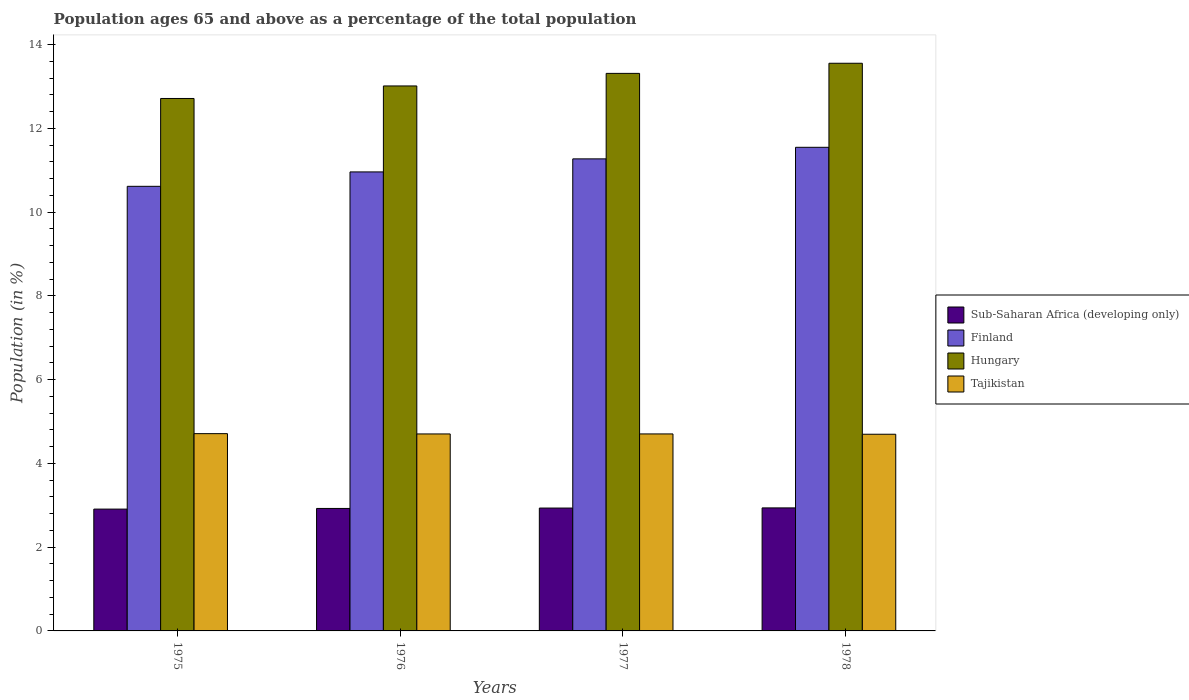How many different coloured bars are there?
Keep it short and to the point. 4. Are the number of bars on each tick of the X-axis equal?
Your answer should be very brief. Yes. How many bars are there on the 4th tick from the right?
Ensure brevity in your answer.  4. What is the label of the 2nd group of bars from the left?
Make the answer very short. 1976. What is the percentage of the population ages 65 and above in Tajikistan in 1975?
Give a very brief answer. 4.71. Across all years, what is the maximum percentage of the population ages 65 and above in Finland?
Offer a very short reply. 11.55. Across all years, what is the minimum percentage of the population ages 65 and above in Hungary?
Offer a terse response. 12.71. In which year was the percentage of the population ages 65 and above in Hungary maximum?
Your response must be concise. 1978. In which year was the percentage of the population ages 65 and above in Tajikistan minimum?
Provide a short and direct response. 1978. What is the total percentage of the population ages 65 and above in Sub-Saharan Africa (developing only) in the graph?
Your response must be concise. 11.7. What is the difference between the percentage of the population ages 65 and above in Hungary in 1976 and that in 1978?
Ensure brevity in your answer.  -0.54. What is the difference between the percentage of the population ages 65 and above in Finland in 1977 and the percentage of the population ages 65 and above in Sub-Saharan Africa (developing only) in 1978?
Offer a terse response. 8.33. What is the average percentage of the population ages 65 and above in Finland per year?
Keep it short and to the point. 11.1. In the year 1975, what is the difference between the percentage of the population ages 65 and above in Finland and percentage of the population ages 65 and above in Tajikistan?
Provide a succinct answer. 5.91. In how many years, is the percentage of the population ages 65 and above in Sub-Saharan Africa (developing only) greater than 0.4?
Provide a succinct answer. 4. What is the ratio of the percentage of the population ages 65 and above in Hungary in 1976 to that in 1977?
Give a very brief answer. 0.98. Is the percentage of the population ages 65 and above in Sub-Saharan Africa (developing only) in 1976 less than that in 1977?
Offer a terse response. Yes. What is the difference between the highest and the second highest percentage of the population ages 65 and above in Finland?
Ensure brevity in your answer.  0.28. What is the difference between the highest and the lowest percentage of the population ages 65 and above in Hungary?
Make the answer very short. 0.84. In how many years, is the percentage of the population ages 65 and above in Tajikistan greater than the average percentage of the population ages 65 and above in Tajikistan taken over all years?
Make the answer very short. 2. Is the sum of the percentage of the population ages 65 and above in Sub-Saharan Africa (developing only) in 1975 and 1976 greater than the maximum percentage of the population ages 65 and above in Tajikistan across all years?
Provide a succinct answer. Yes. What does the 4th bar from the left in 1976 represents?
Offer a terse response. Tajikistan. What does the 4th bar from the right in 1977 represents?
Offer a terse response. Sub-Saharan Africa (developing only). How many bars are there?
Keep it short and to the point. 16. Are all the bars in the graph horizontal?
Give a very brief answer. No. What is the difference between two consecutive major ticks on the Y-axis?
Offer a terse response. 2. Does the graph contain grids?
Provide a short and direct response. No. Where does the legend appear in the graph?
Keep it short and to the point. Center right. What is the title of the graph?
Provide a short and direct response. Population ages 65 and above as a percentage of the total population. What is the label or title of the Y-axis?
Your answer should be very brief. Population (in %). What is the Population (in %) of Sub-Saharan Africa (developing only) in 1975?
Your answer should be compact. 2.91. What is the Population (in %) of Finland in 1975?
Give a very brief answer. 10.62. What is the Population (in %) in Hungary in 1975?
Your response must be concise. 12.71. What is the Population (in %) of Tajikistan in 1975?
Your response must be concise. 4.71. What is the Population (in %) of Sub-Saharan Africa (developing only) in 1976?
Your answer should be compact. 2.92. What is the Population (in %) of Finland in 1976?
Your response must be concise. 10.96. What is the Population (in %) of Hungary in 1976?
Offer a terse response. 13.01. What is the Population (in %) in Tajikistan in 1976?
Your answer should be very brief. 4.7. What is the Population (in %) in Sub-Saharan Africa (developing only) in 1977?
Your response must be concise. 2.93. What is the Population (in %) in Finland in 1977?
Your answer should be very brief. 11.27. What is the Population (in %) of Hungary in 1977?
Your answer should be compact. 13.31. What is the Population (in %) of Tajikistan in 1977?
Make the answer very short. 4.7. What is the Population (in %) of Sub-Saharan Africa (developing only) in 1978?
Offer a very short reply. 2.94. What is the Population (in %) in Finland in 1978?
Provide a succinct answer. 11.55. What is the Population (in %) in Hungary in 1978?
Offer a terse response. 13.55. What is the Population (in %) in Tajikistan in 1978?
Your answer should be compact. 4.7. Across all years, what is the maximum Population (in %) in Sub-Saharan Africa (developing only)?
Provide a succinct answer. 2.94. Across all years, what is the maximum Population (in %) of Finland?
Offer a terse response. 11.55. Across all years, what is the maximum Population (in %) in Hungary?
Give a very brief answer. 13.55. Across all years, what is the maximum Population (in %) of Tajikistan?
Your response must be concise. 4.71. Across all years, what is the minimum Population (in %) in Sub-Saharan Africa (developing only)?
Your answer should be compact. 2.91. Across all years, what is the minimum Population (in %) of Finland?
Your answer should be compact. 10.62. Across all years, what is the minimum Population (in %) of Hungary?
Offer a very short reply. 12.71. Across all years, what is the minimum Population (in %) in Tajikistan?
Ensure brevity in your answer.  4.7. What is the total Population (in %) in Sub-Saharan Africa (developing only) in the graph?
Your response must be concise. 11.7. What is the total Population (in %) of Finland in the graph?
Offer a very short reply. 44.4. What is the total Population (in %) of Hungary in the graph?
Provide a short and direct response. 52.59. What is the total Population (in %) of Tajikistan in the graph?
Your answer should be compact. 18.81. What is the difference between the Population (in %) of Sub-Saharan Africa (developing only) in 1975 and that in 1976?
Make the answer very short. -0.02. What is the difference between the Population (in %) of Finland in 1975 and that in 1976?
Offer a very short reply. -0.34. What is the difference between the Population (in %) of Hungary in 1975 and that in 1976?
Offer a very short reply. -0.3. What is the difference between the Population (in %) of Tajikistan in 1975 and that in 1976?
Your answer should be very brief. 0.01. What is the difference between the Population (in %) in Sub-Saharan Africa (developing only) in 1975 and that in 1977?
Keep it short and to the point. -0.02. What is the difference between the Population (in %) of Finland in 1975 and that in 1977?
Offer a terse response. -0.66. What is the difference between the Population (in %) of Hungary in 1975 and that in 1977?
Give a very brief answer. -0.6. What is the difference between the Population (in %) in Tajikistan in 1975 and that in 1977?
Your answer should be very brief. 0.01. What is the difference between the Population (in %) of Sub-Saharan Africa (developing only) in 1975 and that in 1978?
Your answer should be compact. -0.03. What is the difference between the Population (in %) in Finland in 1975 and that in 1978?
Offer a terse response. -0.93. What is the difference between the Population (in %) of Hungary in 1975 and that in 1978?
Provide a short and direct response. -0.84. What is the difference between the Population (in %) of Tajikistan in 1975 and that in 1978?
Your response must be concise. 0.01. What is the difference between the Population (in %) of Sub-Saharan Africa (developing only) in 1976 and that in 1977?
Make the answer very short. -0.01. What is the difference between the Population (in %) of Finland in 1976 and that in 1977?
Your answer should be compact. -0.31. What is the difference between the Population (in %) in Hungary in 1976 and that in 1977?
Your answer should be compact. -0.3. What is the difference between the Population (in %) of Tajikistan in 1976 and that in 1977?
Your answer should be very brief. -0. What is the difference between the Population (in %) of Sub-Saharan Africa (developing only) in 1976 and that in 1978?
Keep it short and to the point. -0.01. What is the difference between the Population (in %) in Finland in 1976 and that in 1978?
Make the answer very short. -0.59. What is the difference between the Population (in %) in Hungary in 1976 and that in 1978?
Offer a very short reply. -0.54. What is the difference between the Population (in %) in Tajikistan in 1976 and that in 1978?
Offer a very short reply. 0.01. What is the difference between the Population (in %) of Sub-Saharan Africa (developing only) in 1977 and that in 1978?
Offer a very short reply. -0. What is the difference between the Population (in %) in Finland in 1977 and that in 1978?
Keep it short and to the point. -0.28. What is the difference between the Population (in %) of Hungary in 1977 and that in 1978?
Ensure brevity in your answer.  -0.24. What is the difference between the Population (in %) of Tajikistan in 1977 and that in 1978?
Give a very brief answer. 0.01. What is the difference between the Population (in %) in Sub-Saharan Africa (developing only) in 1975 and the Population (in %) in Finland in 1976?
Give a very brief answer. -8.05. What is the difference between the Population (in %) of Sub-Saharan Africa (developing only) in 1975 and the Population (in %) of Hungary in 1976?
Give a very brief answer. -10.1. What is the difference between the Population (in %) in Sub-Saharan Africa (developing only) in 1975 and the Population (in %) in Tajikistan in 1976?
Provide a short and direct response. -1.79. What is the difference between the Population (in %) of Finland in 1975 and the Population (in %) of Hungary in 1976?
Give a very brief answer. -2.4. What is the difference between the Population (in %) of Finland in 1975 and the Population (in %) of Tajikistan in 1976?
Your answer should be compact. 5.91. What is the difference between the Population (in %) of Hungary in 1975 and the Population (in %) of Tajikistan in 1976?
Ensure brevity in your answer.  8.01. What is the difference between the Population (in %) of Sub-Saharan Africa (developing only) in 1975 and the Population (in %) of Finland in 1977?
Keep it short and to the point. -8.36. What is the difference between the Population (in %) of Sub-Saharan Africa (developing only) in 1975 and the Population (in %) of Hungary in 1977?
Your response must be concise. -10.4. What is the difference between the Population (in %) of Sub-Saharan Africa (developing only) in 1975 and the Population (in %) of Tajikistan in 1977?
Your answer should be very brief. -1.79. What is the difference between the Population (in %) in Finland in 1975 and the Population (in %) in Hungary in 1977?
Provide a succinct answer. -2.7. What is the difference between the Population (in %) in Finland in 1975 and the Population (in %) in Tajikistan in 1977?
Make the answer very short. 5.91. What is the difference between the Population (in %) in Hungary in 1975 and the Population (in %) in Tajikistan in 1977?
Ensure brevity in your answer.  8.01. What is the difference between the Population (in %) in Sub-Saharan Africa (developing only) in 1975 and the Population (in %) in Finland in 1978?
Your response must be concise. -8.64. What is the difference between the Population (in %) in Sub-Saharan Africa (developing only) in 1975 and the Population (in %) in Hungary in 1978?
Make the answer very short. -10.65. What is the difference between the Population (in %) of Sub-Saharan Africa (developing only) in 1975 and the Population (in %) of Tajikistan in 1978?
Offer a very short reply. -1.79. What is the difference between the Population (in %) of Finland in 1975 and the Population (in %) of Hungary in 1978?
Ensure brevity in your answer.  -2.94. What is the difference between the Population (in %) in Finland in 1975 and the Population (in %) in Tajikistan in 1978?
Keep it short and to the point. 5.92. What is the difference between the Population (in %) in Hungary in 1975 and the Population (in %) in Tajikistan in 1978?
Your answer should be very brief. 8.02. What is the difference between the Population (in %) of Sub-Saharan Africa (developing only) in 1976 and the Population (in %) of Finland in 1977?
Give a very brief answer. -8.35. What is the difference between the Population (in %) of Sub-Saharan Africa (developing only) in 1976 and the Population (in %) of Hungary in 1977?
Your response must be concise. -10.39. What is the difference between the Population (in %) of Sub-Saharan Africa (developing only) in 1976 and the Population (in %) of Tajikistan in 1977?
Your answer should be very brief. -1.78. What is the difference between the Population (in %) in Finland in 1976 and the Population (in %) in Hungary in 1977?
Provide a short and direct response. -2.35. What is the difference between the Population (in %) in Finland in 1976 and the Population (in %) in Tajikistan in 1977?
Make the answer very short. 6.26. What is the difference between the Population (in %) of Hungary in 1976 and the Population (in %) of Tajikistan in 1977?
Your response must be concise. 8.31. What is the difference between the Population (in %) in Sub-Saharan Africa (developing only) in 1976 and the Population (in %) in Finland in 1978?
Your answer should be very brief. -8.62. What is the difference between the Population (in %) in Sub-Saharan Africa (developing only) in 1976 and the Population (in %) in Hungary in 1978?
Your answer should be compact. -10.63. What is the difference between the Population (in %) in Sub-Saharan Africa (developing only) in 1976 and the Population (in %) in Tajikistan in 1978?
Make the answer very short. -1.77. What is the difference between the Population (in %) of Finland in 1976 and the Population (in %) of Hungary in 1978?
Your response must be concise. -2.59. What is the difference between the Population (in %) in Finland in 1976 and the Population (in %) in Tajikistan in 1978?
Offer a very short reply. 6.26. What is the difference between the Population (in %) in Hungary in 1976 and the Population (in %) in Tajikistan in 1978?
Give a very brief answer. 8.32. What is the difference between the Population (in %) of Sub-Saharan Africa (developing only) in 1977 and the Population (in %) of Finland in 1978?
Offer a terse response. -8.61. What is the difference between the Population (in %) of Sub-Saharan Africa (developing only) in 1977 and the Population (in %) of Hungary in 1978?
Your answer should be compact. -10.62. What is the difference between the Population (in %) in Sub-Saharan Africa (developing only) in 1977 and the Population (in %) in Tajikistan in 1978?
Your answer should be compact. -1.76. What is the difference between the Population (in %) in Finland in 1977 and the Population (in %) in Hungary in 1978?
Give a very brief answer. -2.28. What is the difference between the Population (in %) of Finland in 1977 and the Population (in %) of Tajikistan in 1978?
Offer a terse response. 6.58. What is the difference between the Population (in %) in Hungary in 1977 and the Population (in %) in Tajikistan in 1978?
Your response must be concise. 8.62. What is the average Population (in %) of Sub-Saharan Africa (developing only) per year?
Offer a terse response. 2.93. What is the average Population (in %) in Finland per year?
Your response must be concise. 11.1. What is the average Population (in %) of Hungary per year?
Your answer should be compact. 13.15. What is the average Population (in %) of Tajikistan per year?
Your answer should be very brief. 4.7. In the year 1975, what is the difference between the Population (in %) in Sub-Saharan Africa (developing only) and Population (in %) in Finland?
Keep it short and to the point. -7.71. In the year 1975, what is the difference between the Population (in %) in Sub-Saharan Africa (developing only) and Population (in %) in Hungary?
Give a very brief answer. -9.8. In the year 1975, what is the difference between the Population (in %) of Sub-Saharan Africa (developing only) and Population (in %) of Tajikistan?
Keep it short and to the point. -1.8. In the year 1975, what is the difference between the Population (in %) in Finland and Population (in %) in Hungary?
Ensure brevity in your answer.  -2.1. In the year 1975, what is the difference between the Population (in %) in Finland and Population (in %) in Tajikistan?
Your response must be concise. 5.91. In the year 1975, what is the difference between the Population (in %) in Hungary and Population (in %) in Tajikistan?
Provide a succinct answer. 8. In the year 1976, what is the difference between the Population (in %) of Sub-Saharan Africa (developing only) and Population (in %) of Finland?
Give a very brief answer. -8.04. In the year 1976, what is the difference between the Population (in %) of Sub-Saharan Africa (developing only) and Population (in %) of Hungary?
Offer a terse response. -10.09. In the year 1976, what is the difference between the Population (in %) in Sub-Saharan Africa (developing only) and Population (in %) in Tajikistan?
Provide a succinct answer. -1.78. In the year 1976, what is the difference between the Population (in %) of Finland and Population (in %) of Hungary?
Keep it short and to the point. -2.05. In the year 1976, what is the difference between the Population (in %) in Finland and Population (in %) in Tajikistan?
Offer a terse response. 6.26. In the year 1976, what is the difference between the Population (in %) of Hungary and Population (in %) of Tajikistan?
Make the answer very short. 8.31. In the year 1977, what is the difference between the Population (in %) in Sub-Saharan Africa (developing only) and Population (in %) in Finland?
Ensure brevity in your answer.  -8.34. In the year 1977, what is the difference between the Population (in %) of Sub-Saharan Africa (developing only) and Population (in %) of Hungary?
Your answer should be compact. -10.38. In the year 1977, what is the difference between the Population (in %) in Sub-Saharan Africa (developing only) and Population (in %) in Tajikistan?
Provide a succinct answer. -1.77. In the year 1977, what is the difference between the Population (in %) of Finland and Population (in %) of Hungary?
Offer a very short reply. -2.04. In the year 1977, what is the difference between the Population (in %) in Finland and Population (in %) in Tajikistan?
Provide a succinct answer. 6.57. In the year 1977, what is the difference between the Population (in %) in Hungary and Population (in %) in Tajikistan?
Offer a very short reply. 8.61. In the year 1978, what is the difference between the Population (in %) in Sub-Saharan Africa (developing only) and Population (in %) in Finland?
Offer a very short reply. -8.61. In the year 1978, what is the difference between the Population (in %) in Sub-Saharan Africa (developing only) and Population (in %) in Hungary?
Ensure brevity in your answer.  -10.62. In the year 1978, what is the difference between the Population (in %) in Sub-Saharan Africa (developing only) and Population (in %) in Tajikistan?
Offer a very short reply. -1.76. In the year 1978, what is the difference between the Population (in %) in Finland and Population (in %) in Hungary?
Ensure brevity in your answer.  -2.01. In the year 1978, what is the difference between the Population (in %) of Finland and Population (in %) of Tajikistan?
Provide a succinct answer. 6.85. In the year 1978, what is the difference between the Population (in %) of Hungary and Population (in %) of Tajikistan?
Offer a very short reply. 8.86. What is the ratio of the Population (in %) of Finland in 1975 to that in 1976?
Make the answer very short. 0.97. What is the ratio of the Population (in %) in Finland in 1975 to that in 1977?
Offer a very short reply. 0.94. What is the ratio of the Population (in %) of Hungary in 1975 to that in 1977?
Provide a short and direct response. 0.95. What is the ratio of the Population (in %) of Sub-Saharan Africa (developing only) in 1975 to that in 1978?
Provide a short and direct response. 0.99. What is the ratio of the Population (in %) of Finland in 1975 to that in 1978?
Your response must be concise. 0.92. What is the ratio of the Population (in %) of Hungary in 1975 to that in 1978?
Provide a succinct answer. 0.94. What is the ratio of the Population (in %) of Tajikistan in 1975 to that in 1978?
Provide a short and direct response. 1. What is the ratio of the Population (in %) in Finland in 1976 to that in 1977?
Keep it short and to the point. 0.97. What is the ratio of the Population (in %) of Hungary in 1976 to that in 1977?
Ensure brevity in your answer.  0.98. What is the ratio of the Population (in %) of Sub-Saharan Africa (developing only) in 1976 to that in 1978?
Give a very brief answer. 1. What is the ratio of the Population (in %) of Finland in 1976 to that in 1978?
Ensure brevity in your answer.  0.95. What is the ratio of the Population (in %) of Finland in 1977 to that in 1978?
Give a very brief answer. 0.98. What is the ratio of the Population (in %) of Hungary in 1977 to that in 1978?
Offer a very short reply. 0.98. What is the ratio of the Population (in %) of Tajikistan in 1977 to that in 1978?
Make the answer very short. 1. What is the difference between the highest and the second highest Population (in %) in Sub-Saharan Africa (developing only)?
Provide a short and direct response. 0. What is the difference between the highest and the second highest Population (in %) of Finland?
Give a very brief answer. 0.28. What is the difference between the highest and the second highest Population (in %) in Hungary?
Your answer should be compact. 0.24. What is the difference between the highest and the second highest Population (in %) of Tajikistan?
Offer a terse response. 0.01. What is the difference between the highest and the lowest Population (in %) in Sub-Saharan Africa (developing only)?
Your answer should be very brief. 0.03. What is the difference between the highest and the lowest Population (in %) of Finland?
Keep it short and to the point. 0.93. What is the difference between the highest and the lowest Population (in %) in Hungary?
Keep it short and to the point. 0.84. What is the difference between the highest and the lowest Population (in %) of Tajikistan?
Provide a succinct answer. 0.01. 